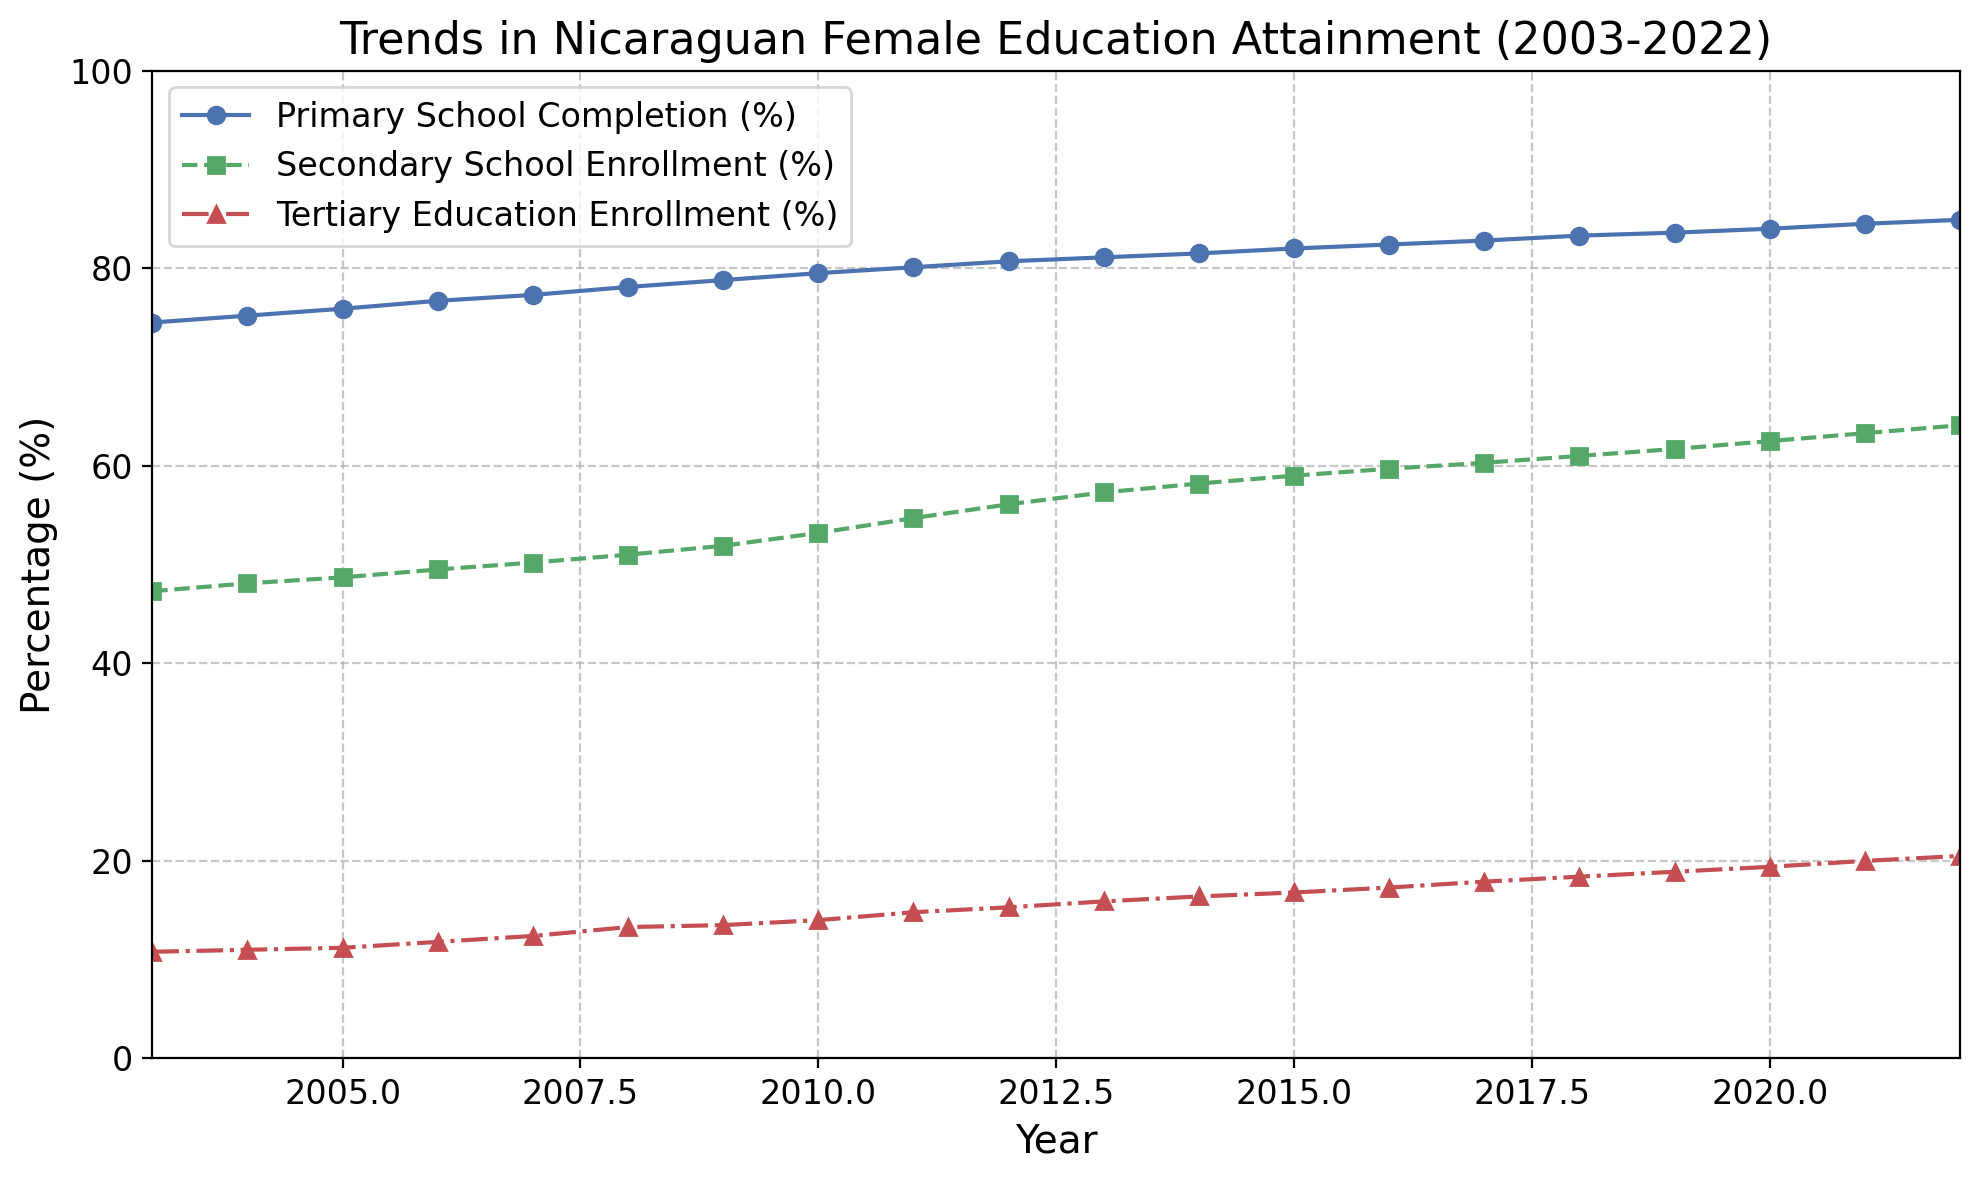What trend does the Primary School Completion (%) show over the 20-year period? The Primary School Completion percentage shows a consistent increasing trend from around 74.5% in 2003 to 84.9% in 2022.
Answer: Increasing By how much did the Tertiary Education Enrollment (%) increase from 2003 to 2022? In 2003, the Tertiary Education Enrollment was 10.8%, and in 2022 it was 20.5%. Subtracting these gives the increase: 20.5% - 10.8% = 9.7%.
Answer: 9.7% Which had a greater percentage increase over the period, Secondary School Enrollment (%) or Tertiary Education Enrollment (%)? The increase in Secondary School Enrollment can be calculated as 64.1% - 47.3% = 16.8%. The increase in Tertiary Education Enrollment is 20.5% - 10.8% = 9.7%. Comparing these, 16.8% is greater than 9.7%.
Answer: Secondary School Enrollment In what year did the Primary School Completion (%) reach 80%? From the chart, the Primary School Completion (%) first reached around 80% in the year 2011.
Answer: 2011 What can you say about the difference between the Primary School Completion (%) and Secondary School Enrollment (%) in 2015? In 2015, the Primary School Completion was 82.0% and Secondary School Enrollment was 59.0%. The difference is 82.0% - 59.0% = 23.0%.
Answer: 23.0% Which education level showed the most significant improvement during the 20 years? By calculating the percentage increases for each level: Primary School Completion increased by 84.9% - 74.5% = 10.4%; Secondary School Enrollment increased by 64.1% - 47.3% = 16.8%; Tertiary Education Enrollment increased by 20.5% - 10.8% = 9.7%. Secondary School Enrollment showed the most significant improvement with an increase of 16.8%.
Answer: Secondary School Enrollment What is the average percentage of Tertiary Education Enrollment over the given period? Summing up the Tertiary Education Enrollment percentages over the 20 years and dividing by 20: (10.8 + 11.0 + 11.2 + 11.8 + 12.4 + 13.3 + 13.5 + 14.0 + 14.8 + 15.3 + 15.9 + 16.4 + 16.8 + 17.3 + 17.9 + 18.4 + 18.9 + 19.4 + 20.0 + 20.5) / 20 = 16.06%.
Answer: 16.06% 